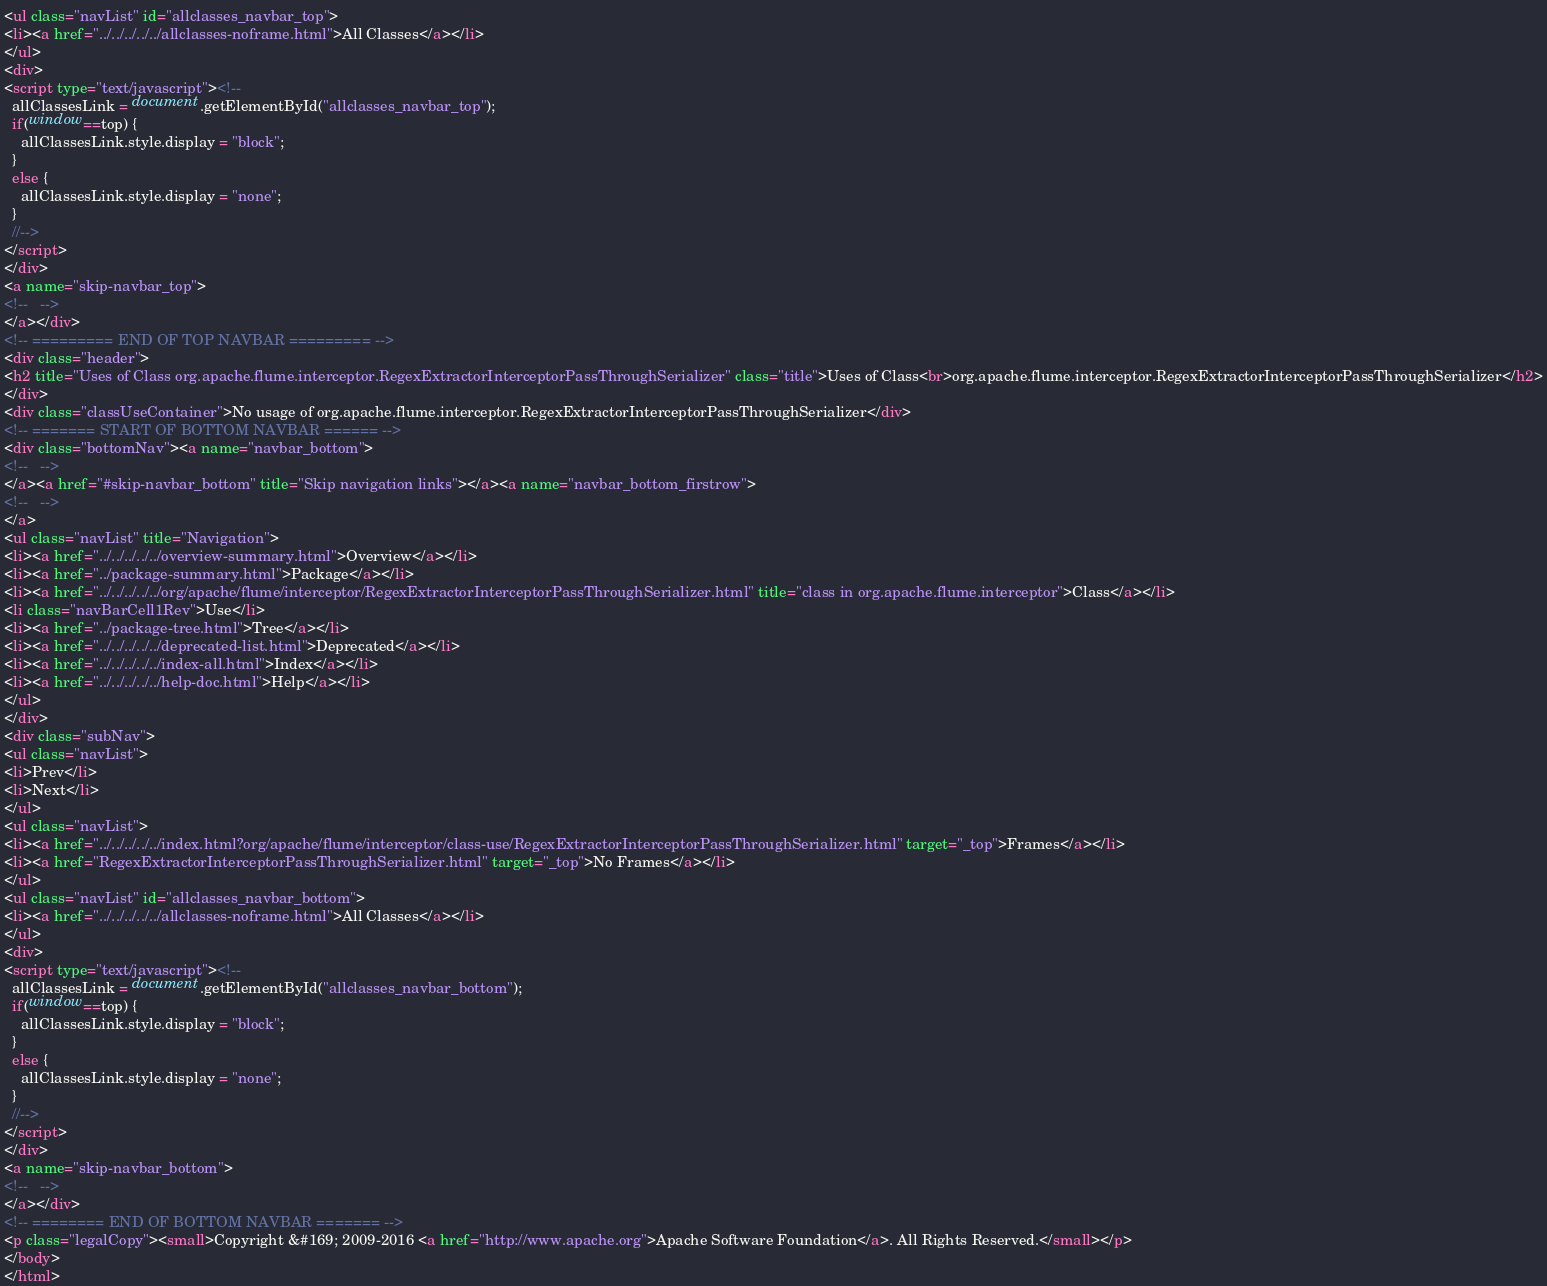Convert code to text. <code><loc_0><loc_0><loc_500><loc_500><_HTML_><ul class="navList" id="allclasses_navbar_top">
<li><a href="../../../../../allclasses-noframe.html">All Classes</a></li>
</ul>
<div>
<script type="text/javascript"><!--
  allClassesLink = document.getElementById("allclasses_navbar_top");
  if(window==top) {
    allClassesLink.style.display = "block";
  }
  else {
    allClassesLink.style.display = "none";
  }
  //-->
</script>
</div>
<a name="skip-navbar_top">
<!--   -->
</a></div>
<!-- ========= END OF TOP NAVBAR ========= -->
<div class="header">
<h2 title="Uses of Class org.apache.flume.interceptor.RegexExtractorInterceptorPassThroughSerializer" class="title">Uses of Class<br>org.apache.flume.interceptor.RegexExtractorInterceptorPassThroughSerializer</h2>
</div>
<div class="classUseContainer">No usage of org.apache.flume.interceptor.RegexExtractorInterceptorPassThroughSerializer</div>
<!-- ======= START OF BOTTOM NAVBAR ====== -->
<div class="bottomNav"><a name="navbar_bottom">
<!--   -->
</a><a href="#skip-navbar_bottom" title="Skip navigation links"></a><a name="navbar_bottom_firstrow">
<!--   -->
</a>
<ul class="navList" title="Navigation">
<li><a href="../../../../../overview-summary.html">Overview</a></li>
<li><a href="../package-summary.html">Package</a></li>
<li><a href="../../../../../org/apache/flume/interceptor/RegexExtractorInterceptorPassThroughSerializer.html" title="class in org.apache.flume.interceptor">Class</a></li>
<li class="navBarCell1Rev">Use</li>
<li><a href="../package-tree.html">Tree</a></li>
<li><a href="../../../../../deprecated-list.html">Deprecated</a></li>
<li><a href="../../../../../index-all.html">Index</a></li>
<li><a href="../../../../../help-doc.html">Help</a></li>
</ul>
</div>
<div class="subNav">
<ul class="navList">
<li>Prev</li>
<li>Next</li>
</ul>
<ul class="navList">
<li><a href="../../../../../index.html?org/apache/flume/interceptor/class-use/RegexExtractorInterceptorPassThroughSerializer.html" target="_top">Frames</a></li>
<li><a href="RegexExtractorInterceptorPassThroughSerializer.html" target="_top">No Frames</a></li>
</ul>
<ul class="navList" id="allclasses_navbar_bottom">
<li><a href="../../../../../allclasses-noframe.html">All Classes</a></li>
</ul>
<div>
<script type="text/javascript"><!--
  allClassesLink = document.getElementById("allclasses_navbar_bottom");
  if(window==top) {
    allClassesLink.style.display = "block";
  }
  else {
    allClassesLink.style.display = "none";
  }
  //-->
</script>
</div>
<a name="skip-navbar_bottom">
<!--   -->
</a></div>
<!-- ======== END OF BOTTOM NAVBAR ======= -->
<p class="legalCopy"><small>Copyright &#169; 2009-2016 <a href="http://www.apache.org">Apache Software Foundation</a>. All Rights Reserved.</small></p>
</body>
</html>
</code> 